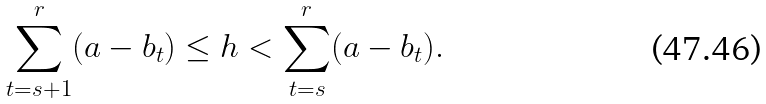Convert formula to latex. <formula><loc_0><loc_0><loc_500><loc_500>\sum _ { t = s + 1 } ^ { r } ( a - b _ { t } ) \leq h < \sum _ { t = s } ^ { r } ( a - b _ { t } ) .</formula> 